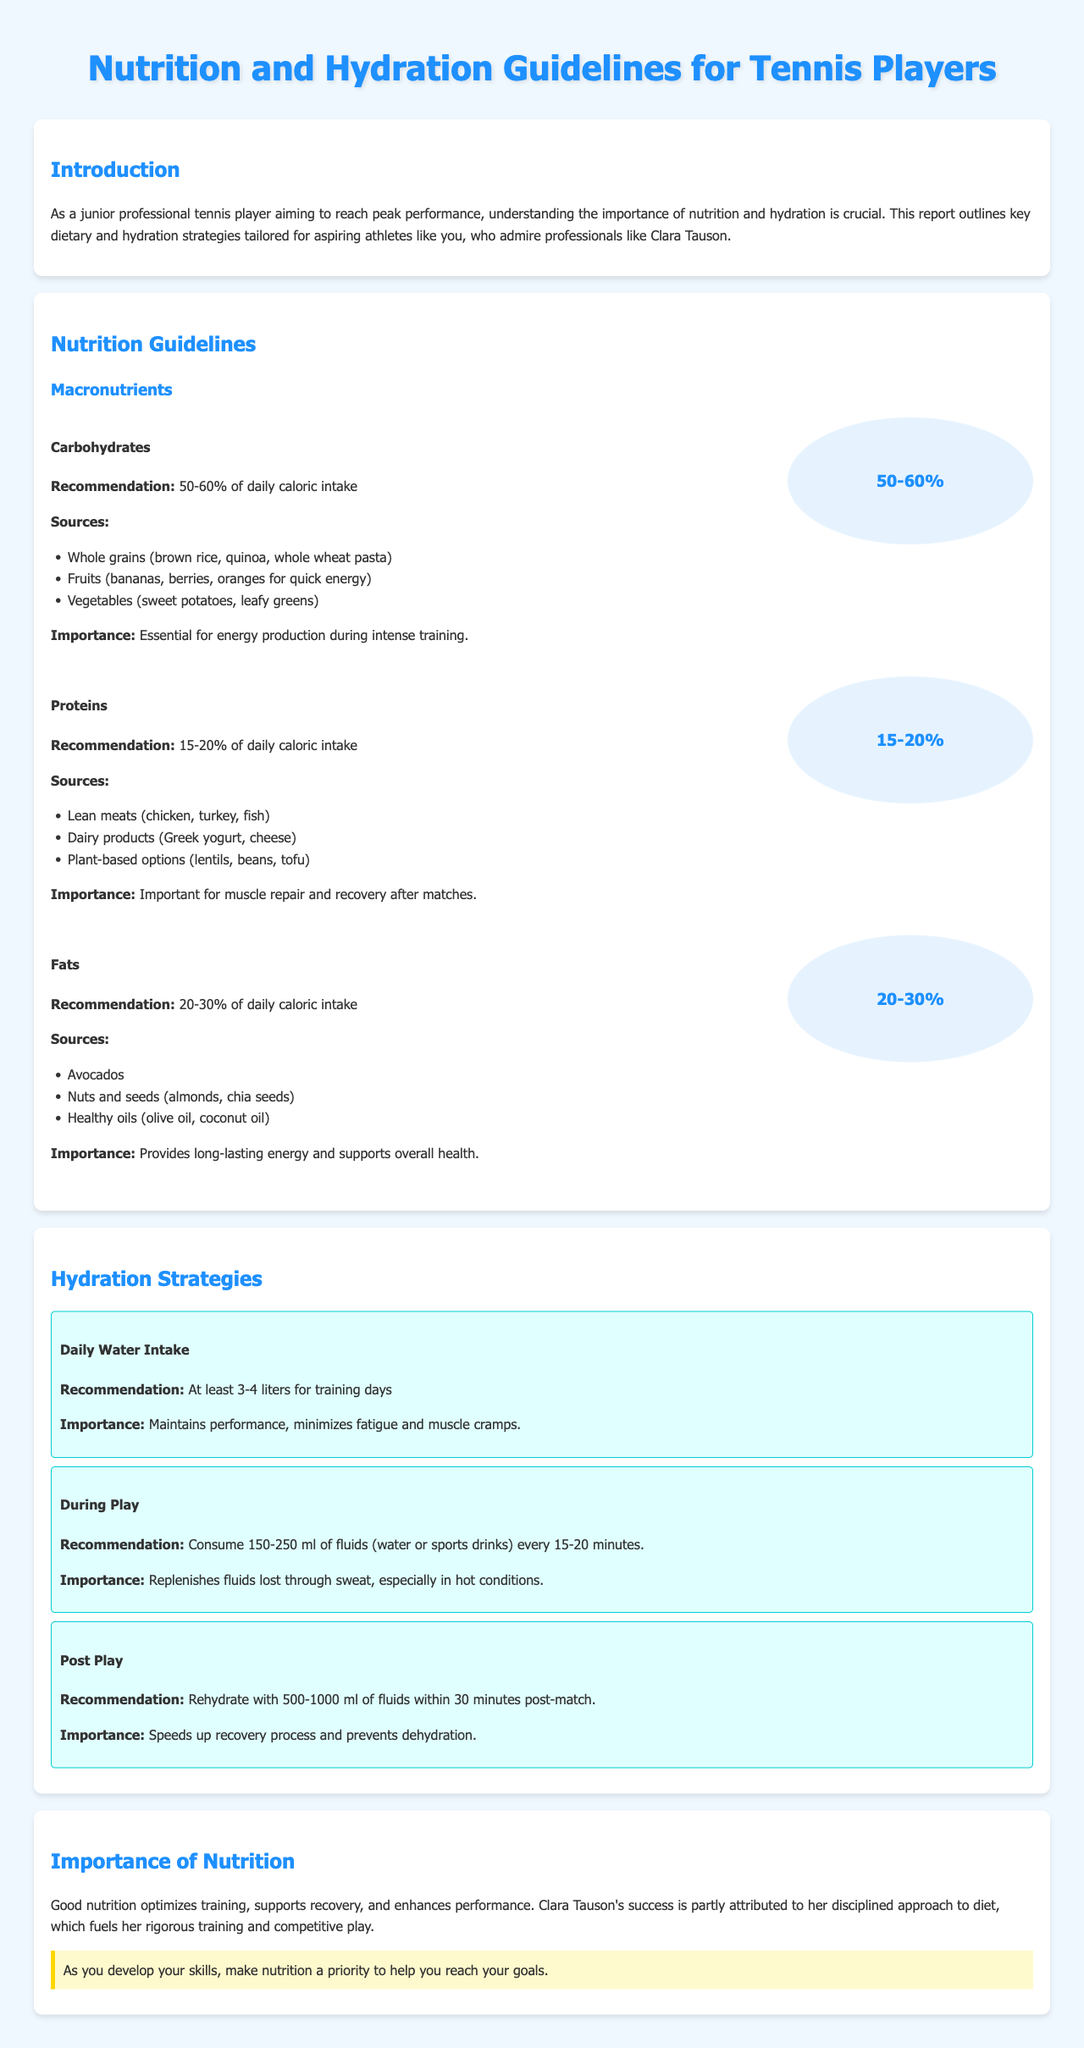What is the recommended daily water intake for training days? The report states that the recommendation for daily water intake on training days is at least 3-4 liters.
Answer: 3-4 liters What percentage of daily caloric intake should carbohydrates make up? According to the document, carbohydrates should account for 50-60% of daily caloric intake.
Answer: 50-60% What is the importance of proteins in a tennis player's diet? The document highlights that proteins are important for muscle repair and recovery after matches.
Answer: Muscle repair and recovery What fluids should be consumed during play? The report recommends consuming water or sports drinks during play.
Answer: Water or sports drinks How much fluid should be consumed post-match? It is specified that 500-1000 ml of fluids should be consumed within 30 minutes post-match.
Answer: 500-1000 ml What role does good nutrition play in athletic performance? The report mentions that good nutrition optimizes training, supports recovery, and enhances performance.
Answer: Optimizes training, supports recovery, enhances performance What is one source of healthy fats mentioned in the document? The report lists avocados as a source of healthy fats.
Answer: Avocados What is the main focus of the introduction section? The introduction emphasizes the importance of nutrition and hydration for peak performance.
Answer: Importance of nutrition and hydration What is a key takeaway regarding Clara Tauson's approach to nutrition? The document notes that her disciplined approach to diet fuels her rigorous training and competitive play.
Answer: Disciplined approach to diet 